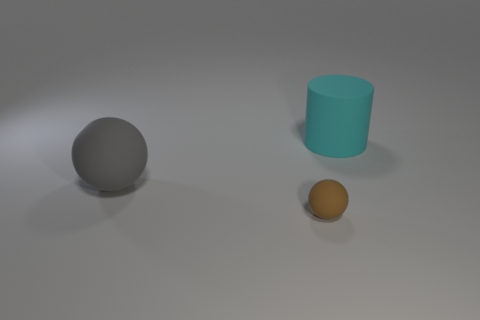Subtract all green cylinders. Subtract all blue balls. How many cylinders are left? 1 Subtract all blue cubes. How many cyan balls are left? 0 Add 3 browns. How many cyans exist? 0 Subtract all large rubber objects. Subtract all big matte balls. How many objects are left? 0 Add 2 gray objects. How many gray objects are left? 3 Add 3 tiny yellow matte cylinders. How many tiny yellow matte cylinders exist? 3 Add 1 cyan rubber things. How many objects exist? 4 Subtract all brown spheres. How many spheres are left? 1 Subtract 0 blue balls. How many objects are left? 3 Subtract all cylinders. How many objects are left? 2 